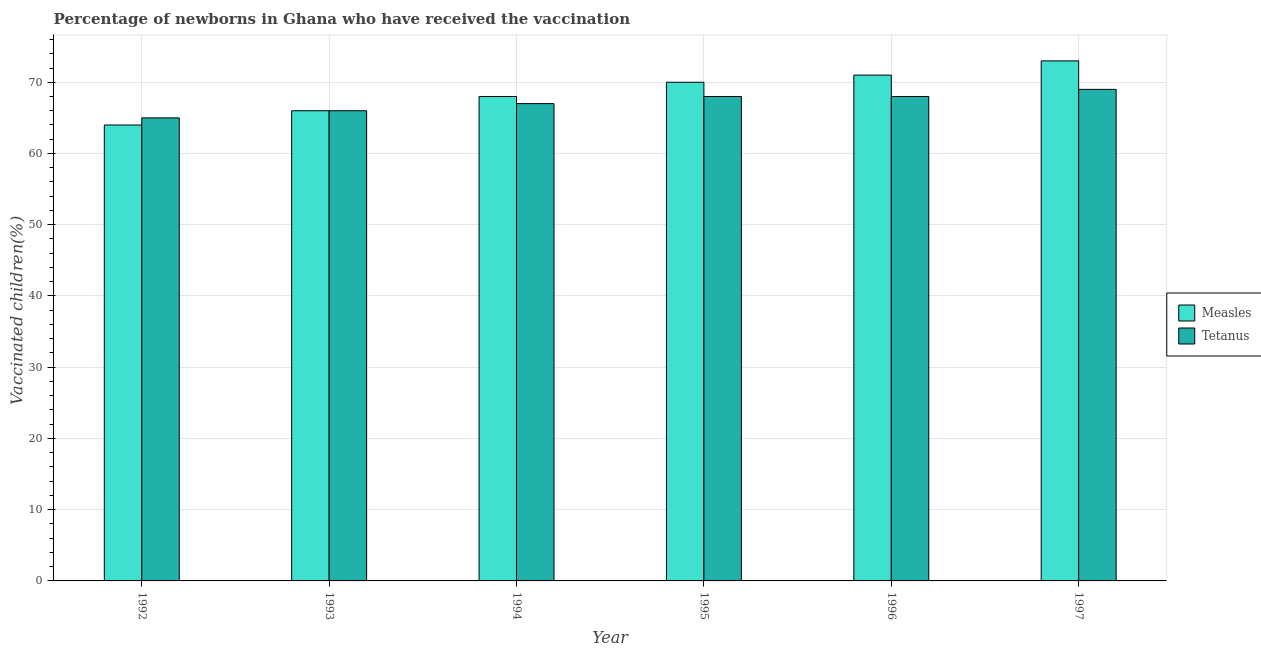How many different coloured bars are there?
Keep it short and to the point. 2. Are the number of bars on each tick of the X-axis equal?
Give a very brief answer. Yes. How many bars are there on the 4th tick from the left?
Your response must be concise. 2. What is the percentage of newborns who received vaccination for measles in 1997?
Your answer should be very brief. 73. Across all years, what is the maximum percentage of newborns who received vaccination for measles?
Provide a succinct answer. 73. Across all years, what is the minimum percentage of newborns who received vaccination for measles?
Make the answer very short. 64. In which year was the percentage of newborns who received vaccination for measles minimum?
Keep it short and to the point. 1992. What is the total percentage of newborns who received vaccination for tetanus in the graph?
Your answer should be very brief. 403. What is the difference between the percentage of newborns who received vaccination for tetanus in 1994 and that in 1995?
Offer a terse response. -1. What is the difference between the percentage of newborns who received vaccination for tetanus in 1995 and the percentage of newborns who received vaccination for measles in 1997?
Keep it short and to the point. -1. What is the average percentage of newborns who received vaccination for measles per year?
Make the answer very short. 68.67. What is the ratio of the percentage of newborns who received vaccination for measles in 1992 to that in 1996?
Offer a terse response. 0.9. Is the percentage of newborns who received vaccination for measles in 1992 less than that in 1995?
Offer a terse response. Yes. What is the difference between the highest and the second highest percentage of newborns who received vaccination for measles?
Make the answer very short. 2. What is the difference between the highest and the lowest percentage of newborns who received vaccination for tetanus?
Your answer should be compact. 4. Is the sum of the percentage of newborns who received vaccination for measles in 1992 and 1994 greater than the maximum percentage of newborns who received vaccination for tetanus across all years?
Your response must be concise. Yes. What does the 2nd bar from the left in 1992 represents?
Offer a very short reply. Tetanus. What does the 2nd bar from the right in 1995 represents?
Offer a terse response. Measles. How many bars are there?
Ensure brevity in your answer.  12. How many years are there in the graph?
Provide a short and direct response. 6. What is the difference between two consecutive major ticks on the Y-axis?
Your response must be concise. 10. Does the graph contain any zero values?
Keep it short and to the point. No. Does the graph contain grids?
Your response must be concise. Yes. What is the title of the graph?
Make the answer very short. Percentage of newborns in Ghana who have received the vaccination. What is the label or title of the X-axis?
Offer a very short reply. Year. What is the label or title of the Y-axis?
Your response must be concise. Vaccinated children(%)
. What is the Vaccinated children(%)
 in Measles in 1993?
Provide a short and direct response. 66. What is the Vaccinated children(%)
 in Tetanus in 1993?
Provide a short and direct response. 66. What is the Vaccinated children(%)
 in Measles in 1994?
Your answer should be compact. 68. What is the Vaccinated children(%)
 of Tetanus in 1994?
Your response must be concise. 67. What is the Vaccinated children(%)
 of Tetanus in 1996?
Your answer should be compact. 68. What is the Vaccinated children(%)
 in Tetanus in 1997?
Your answer should be compact. 69. Across all years, what is the minimum Vaccinated children(%)
 in Tetanus?
Give a very brief answer. 65. What is the total Vaccinated children(%)
 of Measles in the graph?
Your answer should be compact. 412. What is the total Vaccinated children(%)
 of Tetanus in the graph?
Keep it short and to the point. 403. What is the difference between the Vaccinated children(%)
 of Tetanus in 1992 and that in 1993?
Ensure brevity in your answer.  -1. What is the difference between the Vaccinated children(%)
 of Measles in 1992 and that in 1994?
Ensure brevity in your answer.  -4. What is the difference between the Vaccinated children(%)
 of Tetanus in 1992 and that in 1994?
Ensure brevity in your answer.  -2. What is the difference between the Vaccinated children(%)
 in Measles in 1992 and that in 1995?
Your answer should be very brief. -6. What is the difference between the Vaccinated children(%)
 of Tetanus in 1992 and that in 1995?
Make the answer very short. -3. What is the difference between the Vaccinated children(%)
 of Measles in 1992 and that in 1997?
Your answer should be compact. -9. What is the difference between the Vaccinated children(%)
 of Measles in 1993 and that in 1994?
Offer a very short reply. -2. What is the difference between the Vaccinated children(%)
 of Tetanus in 1993 and that in 1994?
Your answer should be compact. -1. What is the difference between the Vaccinated children(%)
 of Measles in 1993 and that in 1995?
Offer a terse response. -4. What is the difference between the Vaccinated children(%)
 in Measles in 1993 and that in 1996?
Give a very brief answer. -5. What is the difference between the Vaccinated children(%)
 of Tetanus in 1993 and that in 1996?
Your answer should be very brief. -2. What is the difference between the Vaccinated children(%)
 of Measles in 1993 and that in 1997?
Make the answer very short. -7. What is the difference between the Vaccinated children(%)
 of Measles in 1994 and that in 1995?
Your response must be concise. -2. What is the difference between the Vaccinated children(%)
 of Tetanus in 1994 and that in 1996?
Ensure brevity in your answer.  -1. What is the difference between the Vaccinated children(%)
 in Measles in 1994 and that in 1997?
Offer a very short reply. -5. What is the difference between the Vaccinated children(%)
 of Tetanus in 1994 and that in 1997?
Give a very brief answer. -2. What is the difference between the Vaccinated children(%)
 in Measles in 1995 and that in 1996?
Keep it short and to the point. -1. What is the difference between the Vaccinated children(%)
 of Tetanus in 1995 and that in 1997?
Keep it short and to the point. -1. What is the difference between the Vaccinated children(%)
 in Measles in 1992 and the Vaccinated children(%)
 in Tetanus in 1993?
Offer a very short reply. -2. What is the difference between the Vaccinated children(%)
 in Measles in 1993 and the Vaccinated children(%)
 in Tetanus in 1995?
Ensure brevity in your answer.  -2. What is the difference between the Vaccinated children(%)
 of Measles in 1993 and the Vaccinated children(%)
 of Tetanus in 1996?
Your response must be concise. -2. What is the difference between the Vaccinated children(%)
 in Measles in 1993 and the Vaccinated children(%)
 in Tetanus in 1997?
Keep it short and to the point. -3. What is the difference between the Vaccinated children(%)
 in Measles in 1994 and the Vaccinated children(%)
 in Tetanus in 1995?
Your answer should be very brief. 0. What is the difference between the Vaccinated children(%)
 in Measles in 1995 and the Vaccinated children(%)
 in Tetanus in 1997?
Provide a succinct answer. 1. What is the difference between the Vaccinated children(%)
 of Measles in 1996 and the Vaccinated children(%)
 of Tetanus in 1997?
Make the answer very short. 2. What is the average Vaccinated children(%)
 in Measles per year?
Make the answer very short. 68.67. What is the average Vaccinated children(%)
 of Tetanus per year?
Ensure brevity in your answer.  67.17. In the year 1992, what is the difference between the Vaccinated children(%)
 of Measles and Vaccinated children(%)
 of Tetanus?
Keep it short and to the point. -1. In the year 1994, what is the difference between the Vaccinated children(%)
 of Measles and Vaccinated children(%)
 of Tetanus?
Make the answer very short. 1. In the year 1997, what is the difference between the Vaccinated children(%)
 of Measles and Vaccinated children(%)
 of Tetanus?
Offer a very short reply. 4. What is the ratio of the Vaccinated children(%)
 in Measles in 1992 to that in 1993?
Give a very brief answer. 0.97. What is the ratio of the Vaccinated children(%)
 in Tetanus in 1992 to that in 1993?
Ensure brevity in your answer.  0.98. What is the ratio of the Vaccinated children(%)
 in Tetanus in 1992 to that in 1994?
Your response must be concise. 0.97. What is the ratio of the Vaccinated children(%)
 in Measles in 1992 to that in 1995?
Offer a very short reply. 0.91. What is the ratio of the Vaccinated children(%)
 in Tetanus in 1992 to that in 1995?
Make the answer very short. 0.96. What is the ratio of the Vaccinated children(%)
 of Measles in 1992 to that in 1996?
Provide a short and direct response. 0.9. What is the ratio of the Vaccinated children(%)
 in Tetanus in 1992 to that in 1996?
Your answer should be compact. 0.96. What is the ratio of the Vaccinated children(%)
 of Measles in 1992 to that in 1997?
Provide a succinct answer. 0.88. What is the ratio of the Vaccinated children(%)
 of Tetanus in 1992 to that in 1997?
Provide a succinct answer. 0.94. What is the ratio of the Vaccinated children(%)
 of Measles in 1993 to that in 1994?
Offer a very short reply. 0.97. What is the ratio of the Vaccinated children(%)
 of Tetanus in 1993 to that in 1994?
Provide a short and direct response. 0.99. What is the ratio of the Vaccinated children(%)
 of Measles in 1993 to that in 1995?
Provide a short and direct response. 0.94. What is the ratio of the Vaccinated children(%)
 of Tetanus in 1993 to that in 1995?
Provide a short and direct response. 0.97. What is the ratio of the Vaccinated children(%)
 of Measles in 1993 to that in 1996?
Ensure brevity in your answer.  0.93. What is the ratio of the Vaccinated children(%)
 in Tetanus in 1993 to that in 1996?
Provide a short and direct response. 0.97. What is the ratio of the Vaccinated children(%)
 of Measles in 1993 to that in 1997?
Your response must be concise. 0.9. What is the ratio of the Vaccinated children(%)
 in Tetanus in 1993 to that in 1997?
Your response must be concise. 0.96. What is the ratio of the Vaccinated children(%)
 of Measles in 1994 to that in 1995?
Offer a terse response. 0.97. What is the ratio of the Vaccinated children(%)
 in Tetanus in 1994 to that in 1995?
Your answer should be compact. 0.99. What is the ratio of the Vaccinated children(%)
 in Measles in 1994 to that in 1996?
Give a very brief answer. 0.96. What is the ratio of the Vaccinated children(%)
 of Tetanus in 1994 to that in 1996?
Your response must be concise. 0.99. What is the ratio of the Vaccinated children(%)
 of Measles in 1994 to that in 1997?
Keep it short and to the point. 0.93. What is the ratio of the Vaccinated children(%)
 in Measles in 1995 to that in 1996?
Your response must be concise. 0.99. What is the ratio of the Vaccinated children(%)
 of Measles in 1995 to that in 1997?
Keep it short and to the point. 0.96. What is the ratio of the Vaccinated children(%)
 in Tetanus in 1995 to that in 1997?
Your response must be concise. 0.99. What is the ratio of the Vaccinated children(%)
 in Measles in 1996 to that in 1997?
Keep it short and to the point. 0.97. What is the ratio of the Vaccinated children(%)
 of Tetanus in 1996 to that in 1997?
Provide a short and direct response. 0.99. What is the difference between the highest and the second highest Vaccinated children(%)
 in Measles?
Provide a short and direct response. 2. What is the difference between the highest and the lowest Vaccinated children(%)
 of Measles?
Your answer should be compact. 9. 